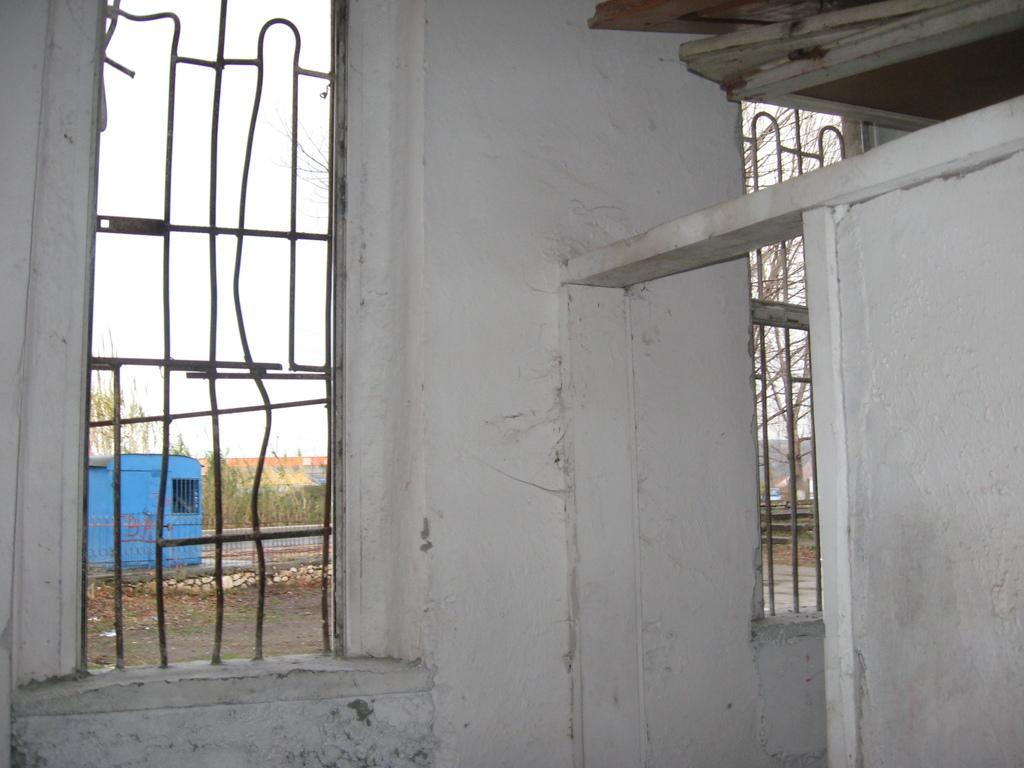What is one of the main structures in the image? There is a wall in the image. What can be seen on the wall? There are windows in the image. What can be seen in the distance in the image? There are trees, stones, and sky visible in the background of the image. What else can be seen in the background of the image? There are some objects in the background of the image. What position does the crate hold in the image? There is no crate present in the image. What is the length of the neck of the tree in the image? There are trees in the background of the image, but they do not have necks, as trees do not have necks like animals. 